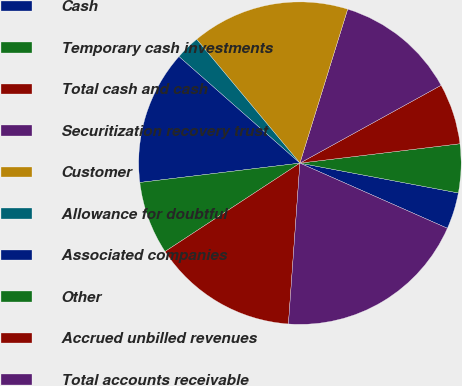Convert chart. <chart><loc_0><loc_0><loc_500><loc_500><pie_chart><fcel>Cash<fcel>Temporary cash investments<fcel>Total cash and cash<fcel>Securitization recovery trust<fcel>Customer<fcel>Allowance for doubtful<fcel>Associated companies<fcel>Other<fcel>Accrued unbilled revenues<fcel>Total accounts receivable<nl><fcel>3.66%<fcel>4.88%<fcel>6.1%<fcel>12.19%<fcel>15.85%<fcel>2.44%<fcel>13.41%<fcel>7.32%<fcel>14.63%<fcel>19.51%<nl></chart> 